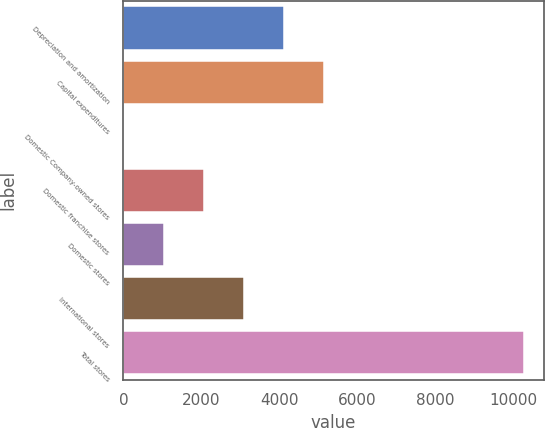Convert chart. <chart><loc_0><loc_0><loc_500><loc_500><bar_chart><fcel>Depreciation and amortization<fcel>Capital expenditures<fcel>Domestic Company-owned stores<fcel>Domestic franchise stores<fcel>Domestic stores<fcel>International stores<fcel>Total stores<nl><fcel>4102.78<fcel>5128.15<fcel>1.3<fcel>2052.04<fcel>1026.67<fcel>3077.41<fcel>10255<nl></chart> 